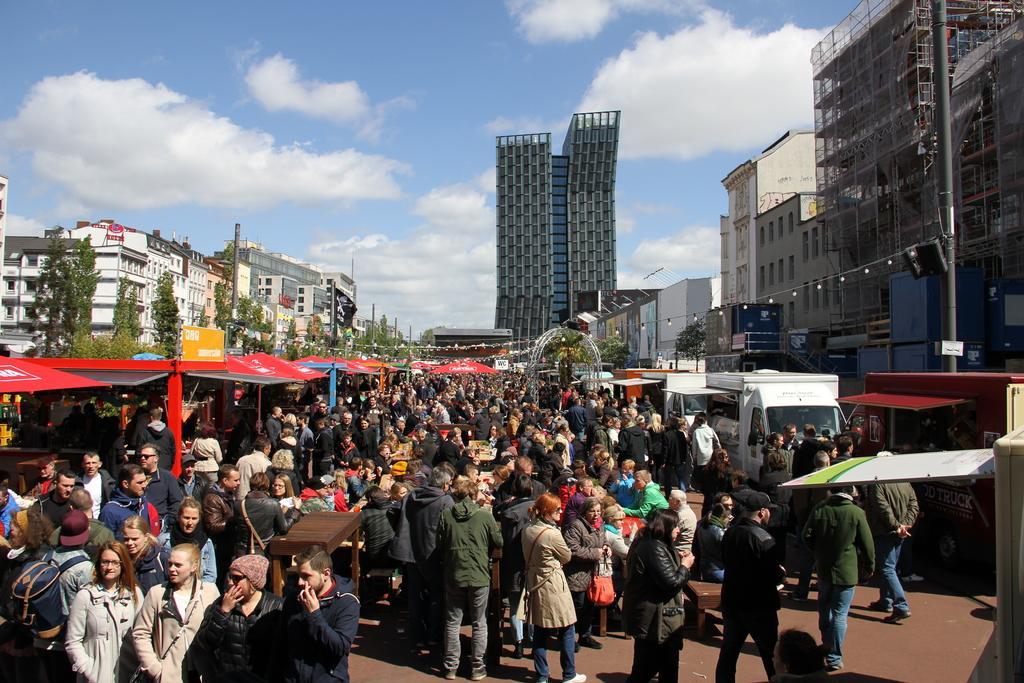Describe this image in one or two sentences. In this image I can see number of people are standing. I can see most of them are wearing jackets and I can see few of them are wearing caps. In the background I can see number of buildings, number of trees, clouds, the sky and I can see few stalls. I can also see a yellow color board over there and on it I can see something is written. 